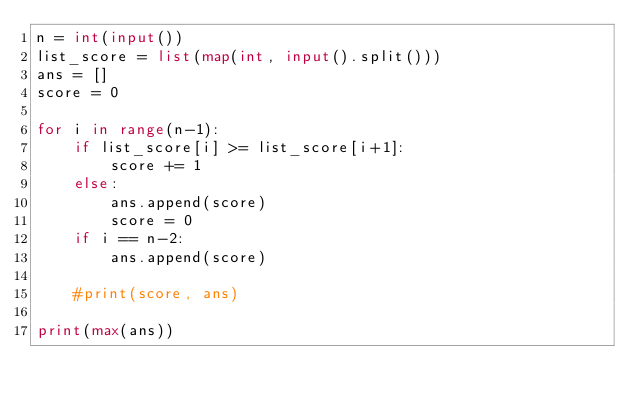<code> <loc_0><loc_0><loc_500><loc_500><_Python_>n = int(input())
list_score = list(map(int, input().split()))
ans = []
score = 0

for i in range(n-1):
    if list_score[i] >= list_score[i+1]:
        score += 1
    else:
        ans.append(score)
        score = 0
    if i == n-2:
        ans.append(score)

    #print(score, ans)

print(max(ans))</code> 